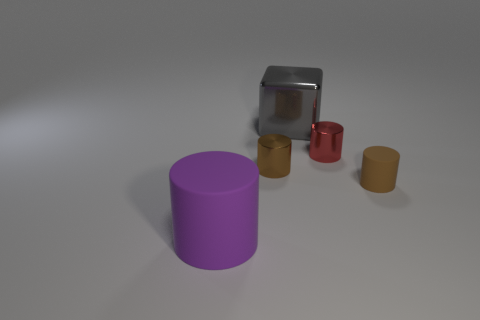Could you describe the lighting in this scene? What mood does it evoke? The lighting in the image is soft and diffused, coming from above and casting gentle shadows beneath the objects. This type of lighting evokes a calm and neutral mood, often used in professional settings to highlight the texture and form of objects without causing harsh reflections or deep shadows that could obscure details. 